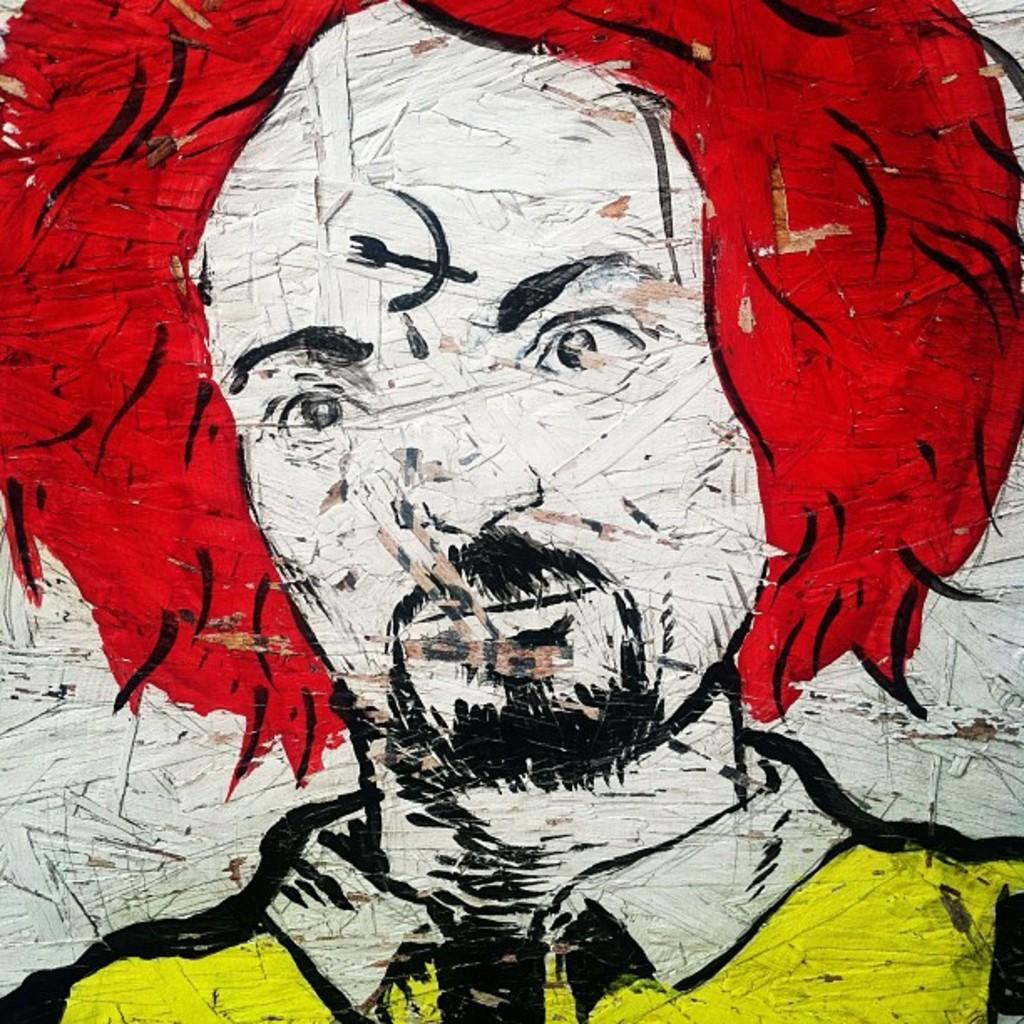Could you give a brief overview of what you see in this image? In this image I can see a painting of a person. 